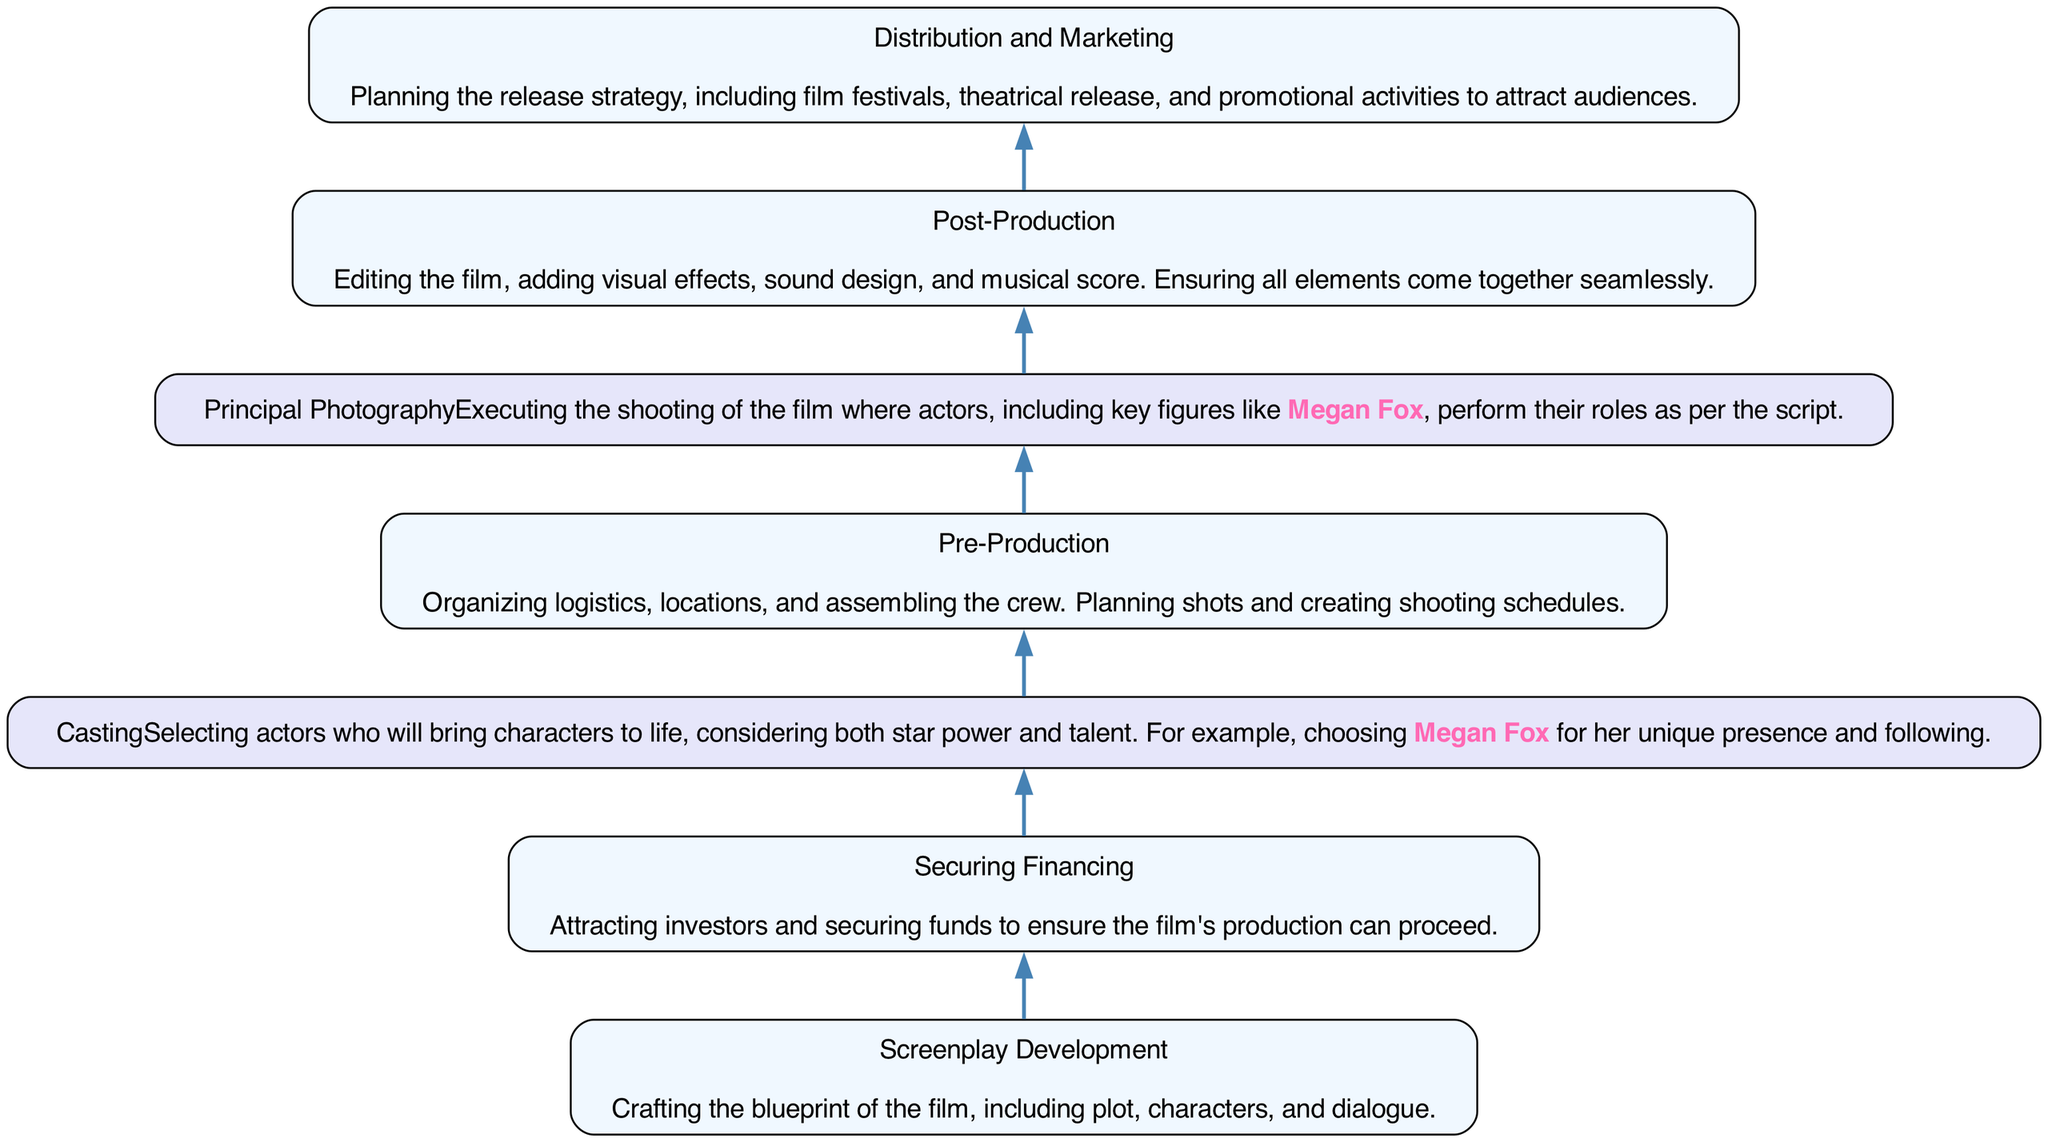What is the first step in the flowchart? The first step in the flowchart, which is at the bottom, is "Screenplay Development." This can be directly identified as it is the first label in the list of steps.
Answer: Screenplay Development How many total steps are there in the diagram? By counting each unique step listed in the flowchart, we find there are seven distinct steps from "Screenplay Development" to "Distribution and Marketing."
Answer: Seven Which step follows "Securing Financing"? By following the flow of the diagram, after "Securing Financing," the next step is "Casting." This is determined by looking directly at the connecting edges in the flowchart.
Answer: Casting What is the last step in the diagram? The last step in the flowchart, positioned at the top, is "Distribution and Marketing." This is the final node that concludes the process outlined in the flow chart.
Answer: Distribution and Marketing Which step specifically mentions Megan Fox? The steps that mention Megan Fox are "Casting" and "Principal Photography." This is identified by reviewing each step's description to look for the name "Megan Fox."
Answer: Casting, Principal Photography How many steps are there between "Pre-Production" and "Screenplay Development"? "Pre-Production" is the fourth step and "Screenplay Development" is the first step. Counting the steps in between gives "Securing Financing" and "Casting," resulting in a total of two intervening steps.
Answer: Two What type of activities are included in "Post-Production"? The activities outlined for "Post-Production" include editing the film, adding visual effects, sound design, and musical score. This can be deduced by the description connected to the "Post-Production" step itself.
Answer: Editing, visual effects, sound design, musical score What is the focus of the "Casting" step? The focus of the "Casting" step involves selecting actors based on talent and star power, specifically mentioning considerations like choosing Megan Fox for her unique presence. This is described in the node related to "Casting."
Answer: Selecting actors How do "Principal Photography" and "Post-Production" relate? "Principal Photography" occurs before "Post-Production" in the flowchart, indicating that filming is completed prior to editing and final touches taking place. This relationship is established by the directional flow from one step to the other.
Answer: Principal Photography precedes Post-Production 